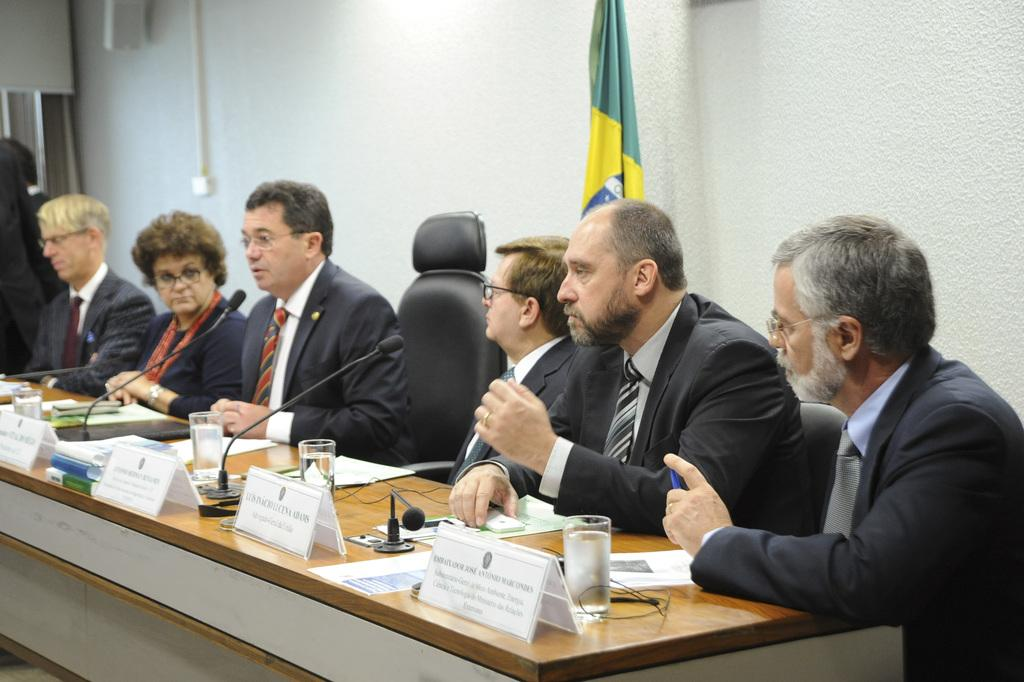What can be seen in the background of the image? There is a wall and a flag in the background of the image. What are the persons in the image doing? The persons are sitting on chairs in front of a table. What objects are on the table? There are mikes, water glasses, and boards on the table. What type of jar is placed in the middle of the table? There is no jar present on the table in the image. How long does it take for the minute hand to move around the clock in the image? There is no clock present in the image, so it is not possible to determine how long it takes for the minute hand to move. 